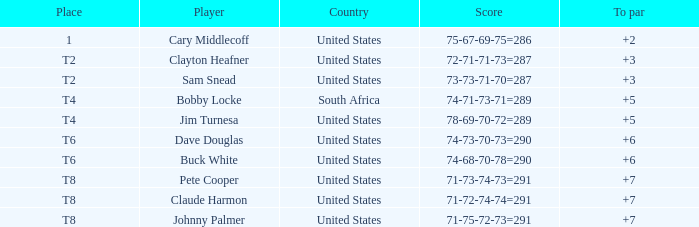What is the Johnny Palmer with a To larger than 6 Money sum? 300.0. 